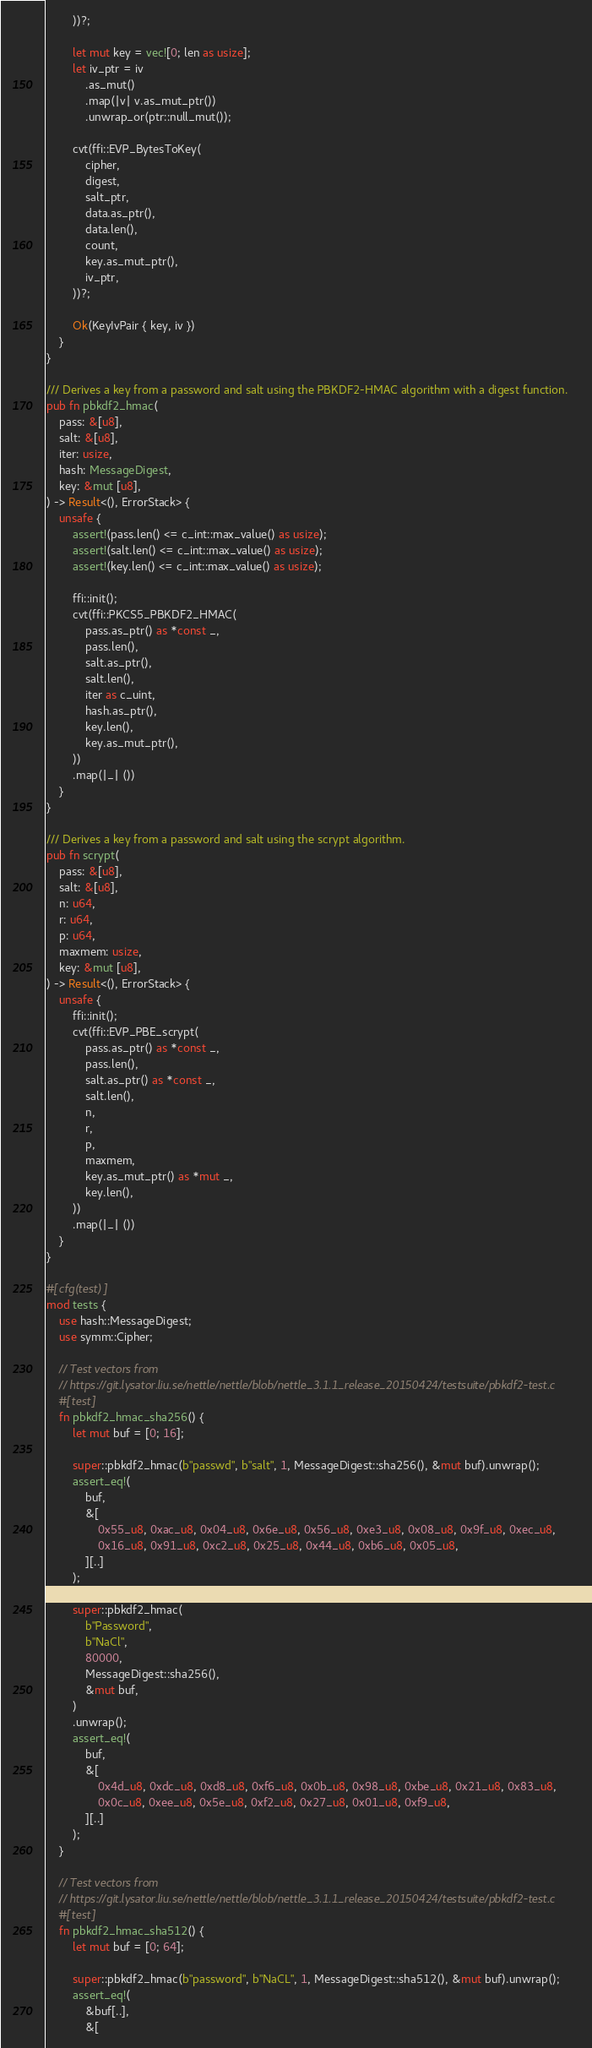<code> <loc_0><loc_0><loc_500><loc_500><_Rust_>        ))?;

        let mut key = vec![0; len as usize];
        let iv_ptr = iv
            .as_mut()
            .map(|v| v.as_mut_ptr())
            .unwrap_or(ptr::null_mut());

        cvt(ffi::EVP_BytesToKey(
            cipher,
            digest,
            salt_ptr,
            data.as_ptr(),
            data.len(),
            count,
            key.as_mut_ptr(),
            iv_ptr,
        ))?;

        Ok(KeyIvPair { key, iv })
    }
}

/// Derives a key from a password and salt using the PBKDF2-HMAC algorithm with a digest function.
pub fn pbkdf2_hmac(
    pass: &[u8],
    salt: &[u8],
    iter: usize,
    hash: MessageDigest,
    key: &mut [u8],
) -> Result<(), ErrorStack> {
    unsafe {
        assert!(pass.len() <= c_int::max_value() as usize);
        assert!(salt.len() <= c_int::max_value() as usize);
        assert!(key.len() <= c_int::max_value() as usize);

        ffi::init();
        cvt(ffi::PKCS5_PBKDF2_HMAC(
            pass.as_ptr() as *const _,
            pass.len(),
            salt.as_ptr(),
            salt.len(),
            iter as c_uint,
            hash.as_ptr(),
            key.len(),
            key.as_mut_ptr(),
        ))
        .map(|_| ())
    }
}

/// Derives a key from a password and salt using the scrypt algorithm.
pub fn scrypt(
    pass: &[u8],
    salt: &[u8],
    n: u64,
    r: u64,
    p: u64,
    maxmem: usize,
    key: &mut [u8],
) -> Result<(), ErrorStack> {
    unsafe {
        ffi::init();
        cvt(ffi::EVP_PBE_scrypt(
            pass.as_ptr() as *const _,
            pass.len(),
            salt.as_ptr() as *const _,
            salt.len(),
            n,
            r,
            p,
            maxmem,
            key.as_mut_ptr() as *mut _,
            key.len(),
        ))
        .map(|_| ())
    }
}

#[cfg(test)]
mod tests {
    use hash::MessageDigest;
    use symm::Cipher;

    // Test vectors from
    // https://git.lysator.liu.se/nettle/nettle/blob/nettle_3.1.1_release_20150424/testsuite/pbkdf2-test.c
    #[test]
    fn pbkdf2_hmac_sha256() {
        let mut buf = [0; 16];

        super::pbkdf2_hmac(b"passwd", b"salt", 1, MessageDigest::sha256(), &mut buf).unwrap();
        assert_eq!(
            buf,
            &[
                0x55_u8, 0xac_u8, 0x04_u8, 0x6e_u8, 0x56_u8, 0xe3_u8, 0x08_u8, 0x9f_u8, 0xec_u8,
                0x16_u8, 0x91_u8, 0xc2_u8, 0x25_u8, 0x44_u8, 0xb6_u8, 0x05_u8,
            ][..]
        );

        super::pbkdf2_hmac(
            b"Password",
            b"NaCl",
            80000,
            MessageDigest::sha256(),
            &mut buf,
        )
        .unwrap();
        assert_eq!(
            buf,
            &[
                0x4d_u8, 0xdc_u8, 0xd8_u8, 0xf6_u8, 0x0b_u8, 0x98_u8, 0xbe_u8, 0x21_u8, 0x83_u8,
                0x0c_u8, 0xee_u8, 0x5e_u8, 0xf2_u8, 0x27_u8, 0x01_u8, 0xf9_u8,
            ][..]
        );
    }

    // Test vectors from
    // https://git.lysator.liu.se/nettle/nettle/blob/nettle_3.1.1_release_20150424/testsuite/pbkdf2-test.c
    #[test]
    fn pbkdf2_hmac_sha512() {
        let mut buf = [0; 64];

        super::pbkdf2_hmac(b"password", b"NaCL", 1, MessageDigest::sha512(), &mut buf).unwrap();
        assert_eq!(
            &buf[..],
            &[</code> 